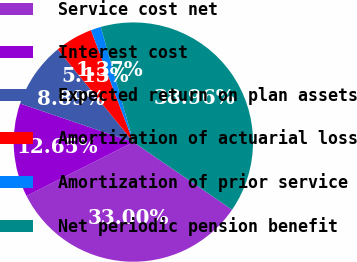<chart> <loc_0><loc_0><loc_500><loc_500><pie_chart><fcel>Service cost net<fcel>Interest cost<fcel>Expected return on plan assets<fcel>Amortization of actuarial loss<fcel>Amortization of prior service<fcel>Net periodic pension benefit<nl><fcel>33.0%<fcel>12.65%<fcel>8.89%<fcel>5.13%<fcel>1.37%<fcel>38.96%<nl></chart> 